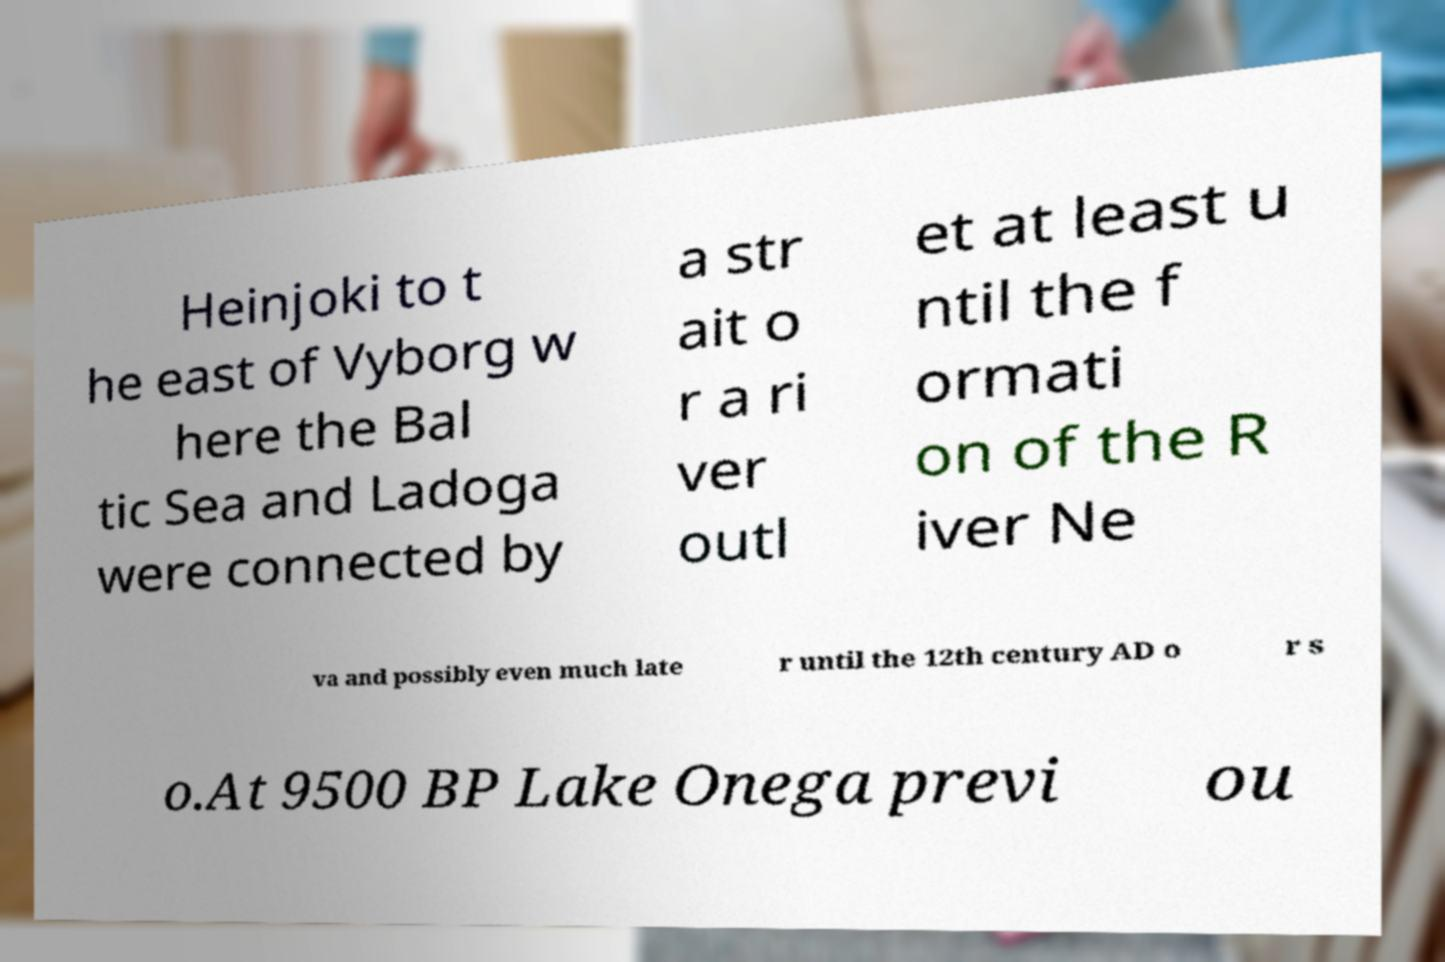What messages or text are displayed in this image? I need them in a readable, typed format. Heinjoki to t he east of Vyborg w here the Bal tic Sea and Ladoga were connected by a str ait o r a ri ver outl et at least u ntil the f ormati on of the R iver Ne va and possibly even much late r until the 12th century AD o r s o.At 9500 BP Lake Onega previ ou 